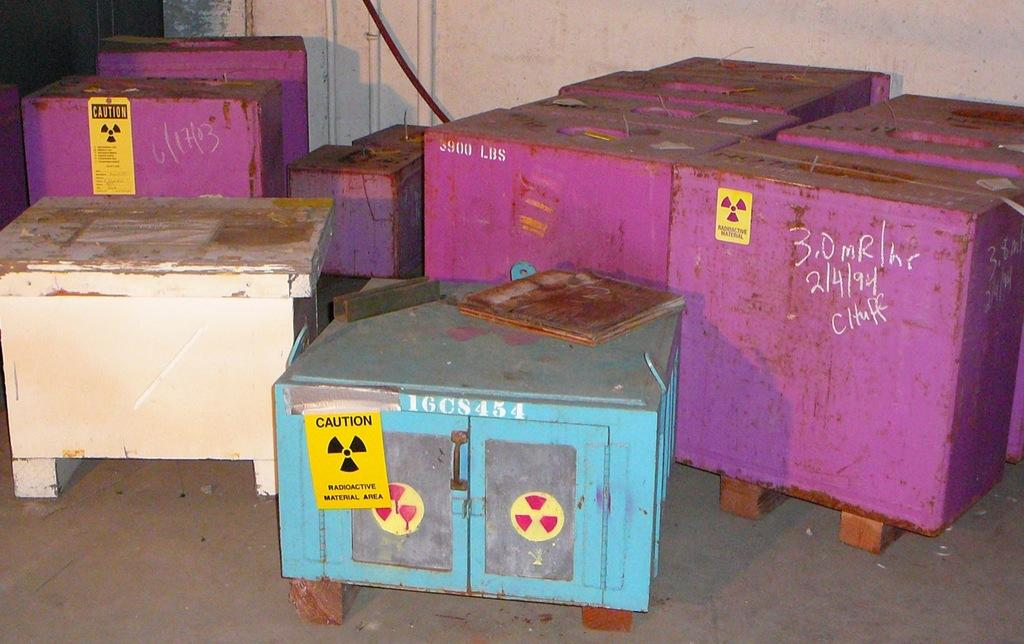<image>
Present a compact description of the photo's key features. 3 Boxes all marked radio active, one blue, one white, and one pink. There is also a white box. 